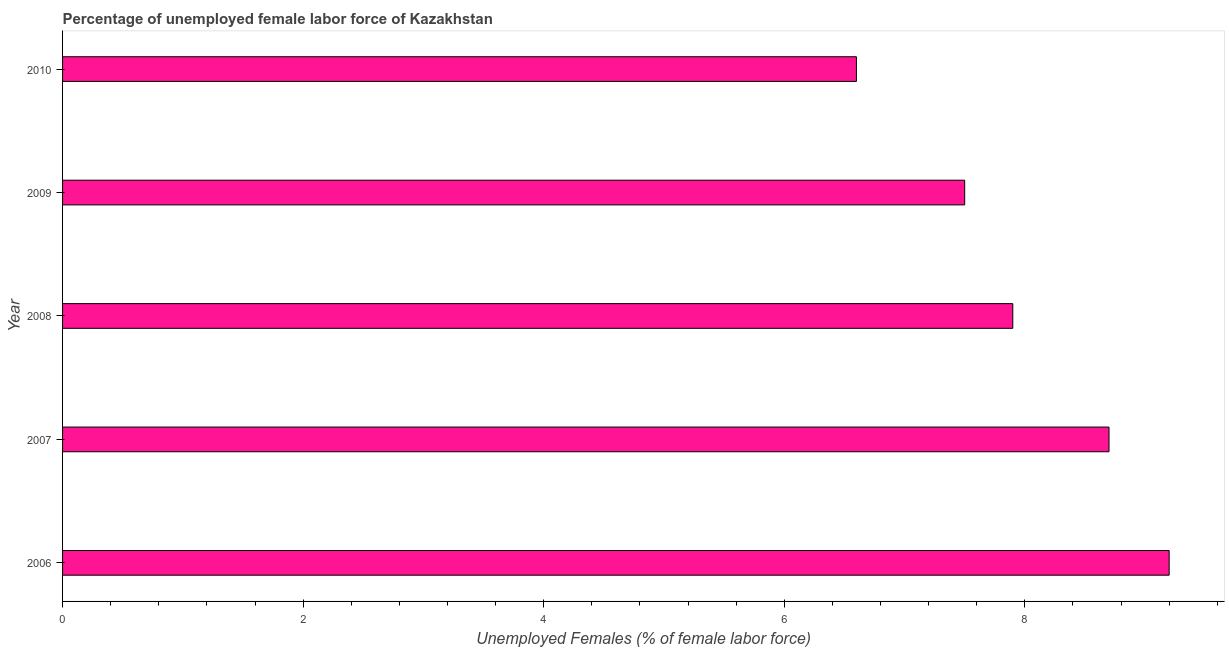Does the graph contain any zero values?
Ensure brevity in your answer.  No. Does the graph contain grids?
Keep it short and to the point. No. What is the title of the graph?
Your answer should be very brief. Percentage of unemployed female labor force of Kazakhstan. What is the label or title of the X-axis?
Keep it short and to the point. Unemployed Females (% of female labor force). Across all years, what is the maximum total unemployed female labour force?
Offer a very short reply. 9.2. Across all years, what is the minimum total unemployed female labour force?
Give a very brief answer. 6.6. What is the sum of the total unemployed female labour force?
Offer a very short reply. 39.9. What is the average total unemployed female labour force per year?
Provide a succinct answer. 7.98. What is the median total unemployed female labour force?
Give a very brief answer. 7.9. In how many years, is the total unemployed female labour force greater than 7.6 %?
Provide a succinct answer. 3. What is the ratio of the total unemployed female labour force in 2006 to that in 2010?
Ensure brevity in your answer.  1.39. What is the difference between the highest and the second highest total unemployed female labour force?
Ensure brevity in your answer.  0.5. Is the sum of the total unemployed female labour force in 2008 and 2010 greater than the maximum total unemployed female labour force across all years?
Your answer should be compact. Yes. Are the values on the major ticks of X-axis written in scientific E-notation?
Your answer should be compact. No. What is the Unemployed Females (% of female labor force) in 2006?
Your answer should be compact. 9.2. What is the Unemployed Females (% of female labor force) of 2007?
Provide a succinct answer. 8.7. What is the Unemployed Females (% of female labor force) in 2008?
Provide a short and direct response. 7.9. What is the Unemployed Females (% of female labor force) in 2010?
Make the answer very short. 6.6. What is the difference between the Unemployed Females (% of female labor force) in 2006 and 2007?
Ensure brevity in your answer.  0.5. What is the difference between the Unemployed Females (% of female labor force) in 2006 and 2008?
Provide a short and direct response. 1.3. What is the difference between the Unemployed Females (% of female labor force) in 2006 and 2010?
Provide a short and direct response. 2.6. What is the difference between the Unemployed Females (% of female labor force) in 2007 and 2009?
Your answer should be very brief. 1.2. What is the difference between the Unemployed Females (% of female labor force) in 2007 and 2010?
Your answer should be compact. 2.1. What is the difference between the Unemployed Females (% of female labor force) in 2008 and 2009?
Keep it short and to the point. 0.4. What is the difference between the Unemployed Females (% of female labor force) in 2008 and 2010?
Keep it short and to the point. 1.3. What is the difference between the Unemployed Females (% of female labor force) in 2009 and 2010?
Ensure brevity in your answer.  0.9. What is the ratio of the Unemployed Females (% of female labor force) in 2006 to that in 2007?
Your answer should be compact. 1.06. What is the ratio of the Unemployed Females (% of female labor force) in 2006 to that in 2008?
Ensure brevity in your answer.  1.17. What is the ratio of the Unemployed Females (% of female labor force) in 2006 to that in 2009?
Ensure brevity in your answer.  1.23. What is the ratio of the Unemployed Females (% of female labor force) in 2006 to that in 2010?
Ensure brevity in your answer.  1.39. What is the ratio of the Unemployed Females (% of female labor force) in 2007 to that in 2008?
Give a very brief answer. 1.1. What is the ratio of the Unemployed Females (% of female labor force) in 2007 to that in 2009?
Ensure brevity in your answer.  1.16. What is the ratio of the Unemployed Females (% of female labor force) in 2007 to that in 2010?
Offer a terse response. 1.32. What is the ratio of the Unemployed Females (% of female labor force) in 2008 to that in 2009?
Give a very brief answer. 1.05. What is the ratio of the Unemployed Females (% of female labor force) in 2008 to that in 2010?
Ensure brevity in your answer.  1.2. What is the ratio of the Unemployed Females (% of female labor force) in 2009 to that in 2010?
Keep it short and to the point. 1.14. 